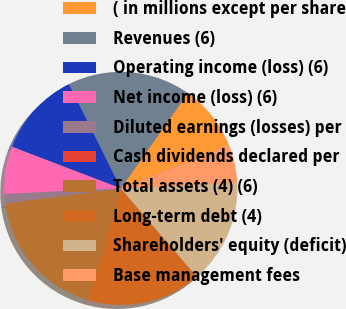Convert chart. <chart><loc_0><loc_0><loc_500><loc_500><pie_chart><fcel>( in millions except per share<fcel>Revenues (6)<fcel>Operating income (loss) (6)<fcel>Net income (loss) (6)<fcel>Diluted earnings (losses) per<fcel>Cash dividends declared per<fcel>Total assets (4) (6)<fcel>Long-term debt (4)<fcel>Shareholders' equity (deficit)<fcel>Base management fees<nl><fcel>9.21%<fcel>17.1%<fcel>11.84%<fcel>6.58%<fcel>1.32%<fcel>0.0%<fcel>18.42%<fcel>15.79%<fcel>14.47%<fcel>5.26%<nl></chart> 